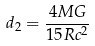<formula> <loc_0><loc_0><loc_500><loc_500>d _ { 2 } = \frac { 4 M G } { 1 5 R c ^ { 2 } }</formula> 